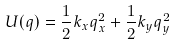Convert formula to latex. <formula><loc_0><loc_0><loc_500><loc_500>U ( { q } ) = \frac { 1 } { 2 } k _ { x } q _ { x } ^ { 2 } + \frac { 1 } { 2 } k _ { y } q _ { y } ^ { 2 }</formula> 